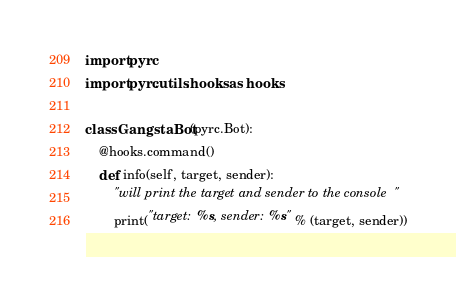<code> <loc_0><loc_0><loc_500><loc_500><_Python_>import pyrc
import pyrc.utils.hooks as hooks

class GangstaBot(pyrc.Bot):
    @hooks.command()
    def info(self, target, sender):
        "will print the target and sender to the console"
        print("target: %s, sender: %s" % (target, sender))
</code> 